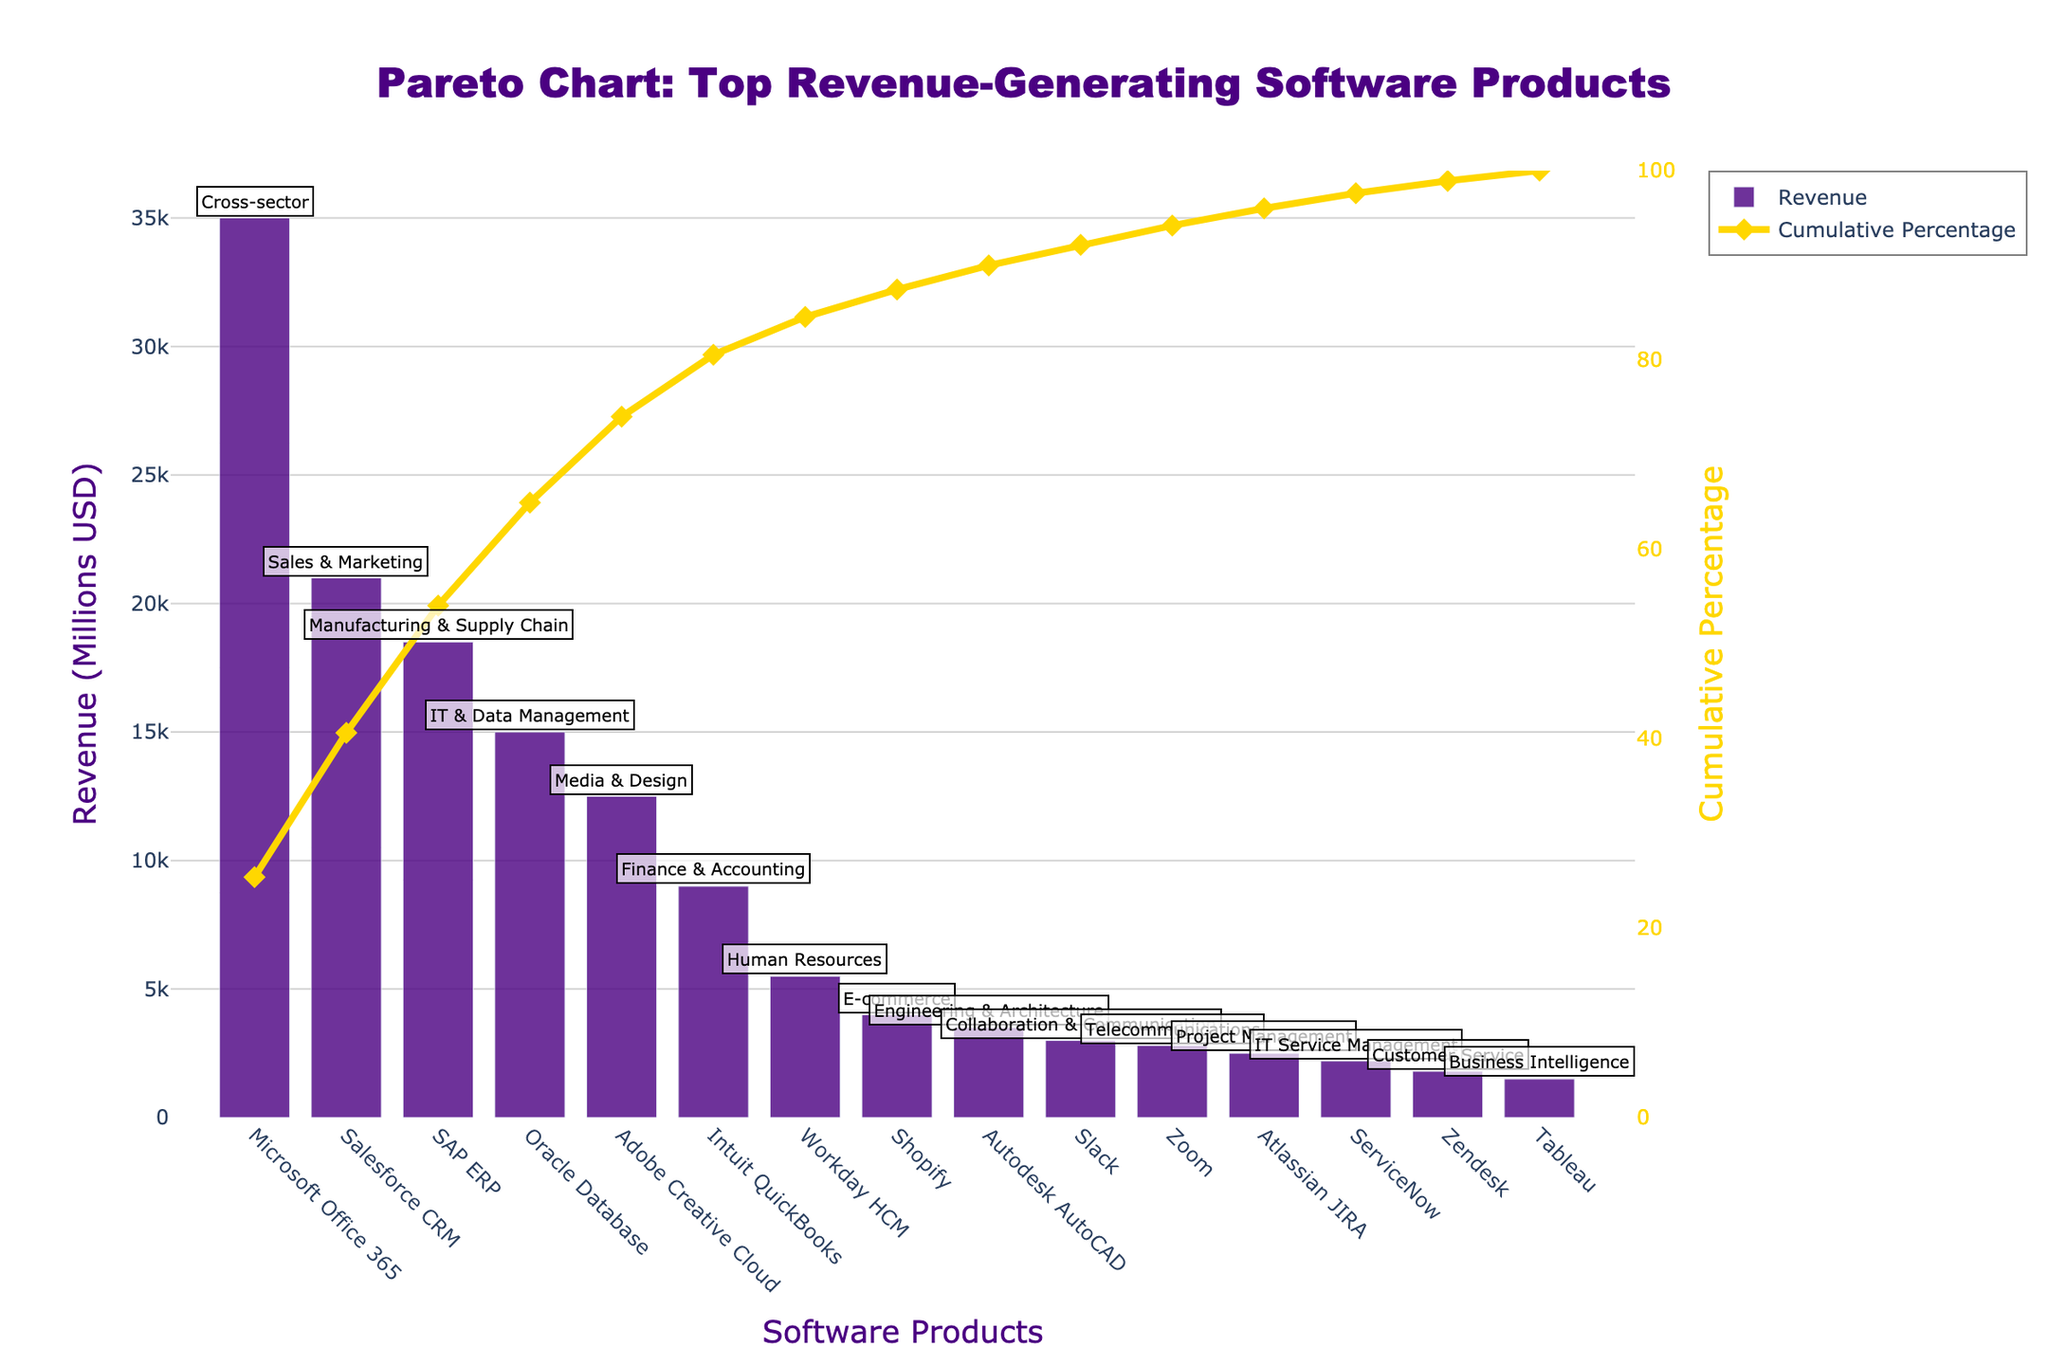What is the title of the chart? The chart title is provided at the top center of the figure. It reads "Pareto Chart: Top Revenue-Generating Software Products".
Answer: Pareto Chart: Top Revenue-Generating Software Products Which software product generated the highest revenue? The software product at the beginning of the bar chart with the highest revenue bar is Microsoft Office 365.
Answer: Microsoft Office 365 What is the cumulative percentage for Salesforce CRM? Locate the point corresponding to Salesforce CRM on the Cumulative Percentage line (y2-axis) and read the percentage value.
Answer: Approximately 27% How much revenue was generated by all products combined from SAP ERP to Zoom? Sum the revenue values for SAP ERP, Oracle Database, Adobe Creative Cloud, Intuit QuickBooks, Autodesk AutoCAD, Workday HCM, Shopify, Slack, and Zoom.
Answer: 69,600 million USD How does the revenue of Oracle Database compare to Adobe Creative Cloud? Compare the heights of the bars for Oracle Database and Adobe Creative Cloud. Oracle Database has a higher bar than Adobe Creative Cloud.
Answer: Oracle Database has higher revenue Which product falls under the Media & Design industry sector? Check the annotations near the bars. The annotation next to Adobe Creative Cloud indicates it belongs to the Media & Design sector.
Answer: Adobe Creative Cloud What is the cumulative percentage after the top 3 products? Sum the revenues for the top 3 products (Microsoft Office 365, Salesforce CRM, SAP ERP) and divide by the total revenue, then multiply by 100. Alternatively, read the Cumulative Percentage value at the third product on the line.
Answer: Approximately 67% How does the combined revenue of products in the IT & Data Management sector compare to those in the Project Management sector? Sum the revenue for all products in the respective sectors. IT & Data Management has one product (Oracle Database: 15,000 million USD) and Project Management has one product (Atlassian JIRA: 2,500 million USD). Compare the sums.
Answer: IT & Data Management > Project Management Which product marks the 80% cumulative percentage threshold? Follow the Cumulative Percentage line to where it intersects the 80% mark on the y2-axis, then move vertically down to the corresponding product.
Answer: Intuit QuickBooks What is the cumulative revenue for the top five products? Sum the revenues for the top five products: Microsoft Office 365, Salesforce CRM, SAP ERP, Oracle Database, Adobe Creative Cloud.
Answer: 102,000 million USD 